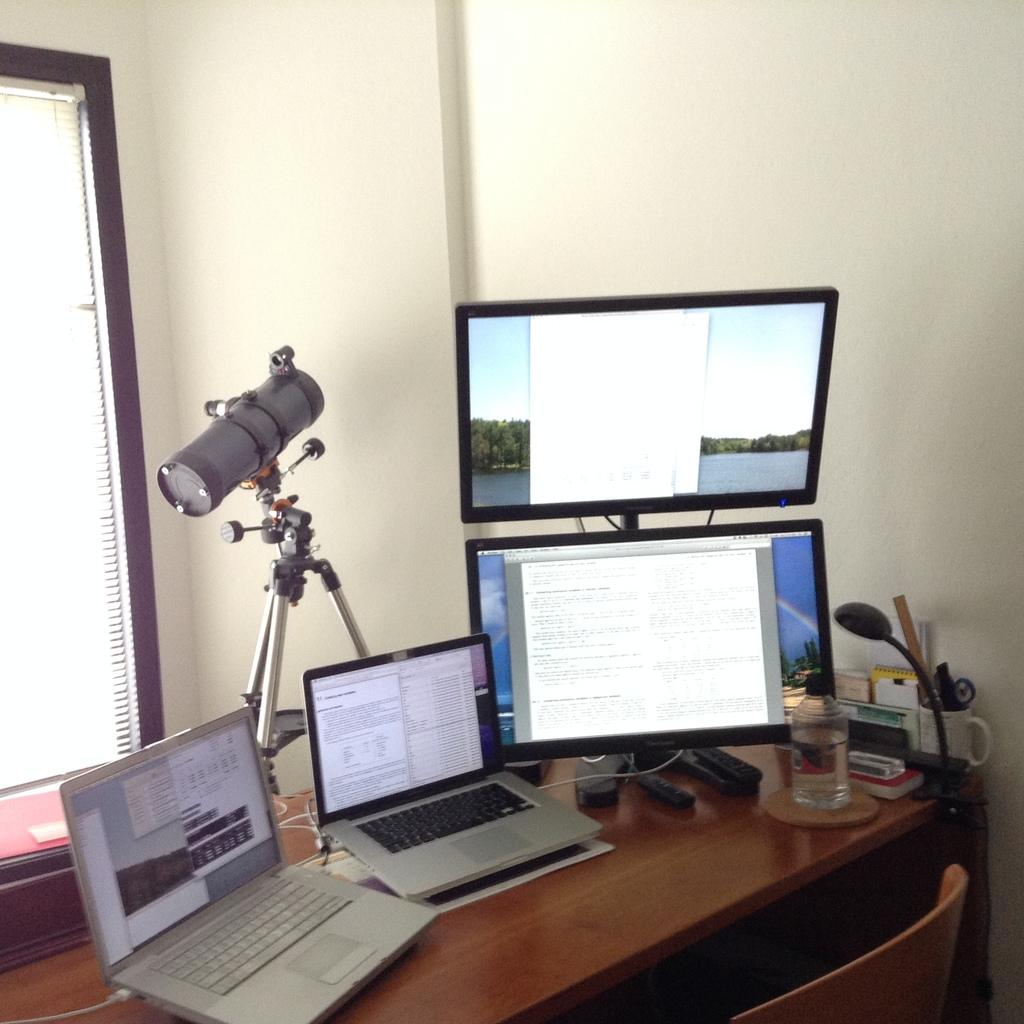What electronic device is on the table in the image? There is a laptop on the table in the image. What other electronic device is on the table? There is a monitor on the table. What type of objects are on the table that are not electronic devices? There is a bottle and a cup on the table. What type of furniture is in the image? There is a chair in the image. What type of teeth can be seen in the image? There are no teeth present in the image. What type of pump is visible in the image? There is no pump present in the image. 